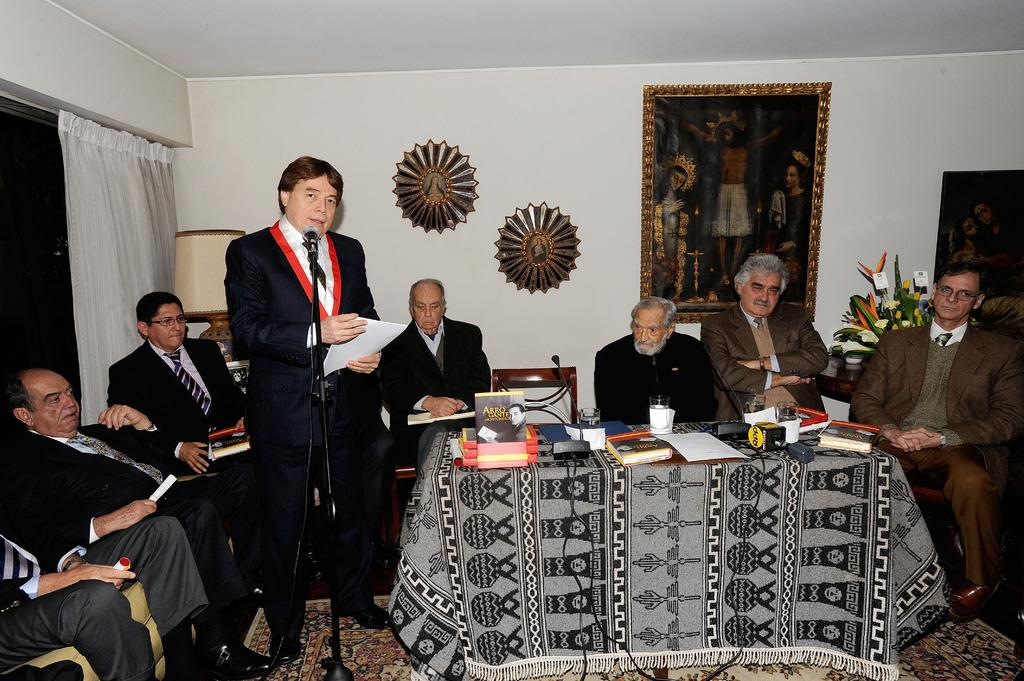Who is present in the image? There are people in the image. What are the people doing in the image? The people are sitting on chairs. Can you describe the man in the image? There is a man standing in front of a microphone. What is the purpose of the table in the image? There is a table in the image, and there are items on it. What type of toothpaste is being used by the people in the image? There is no toothpaste present in the image. What fact is being discussed by the people in the image? The image does not provide information about any specific facts being discussed. 